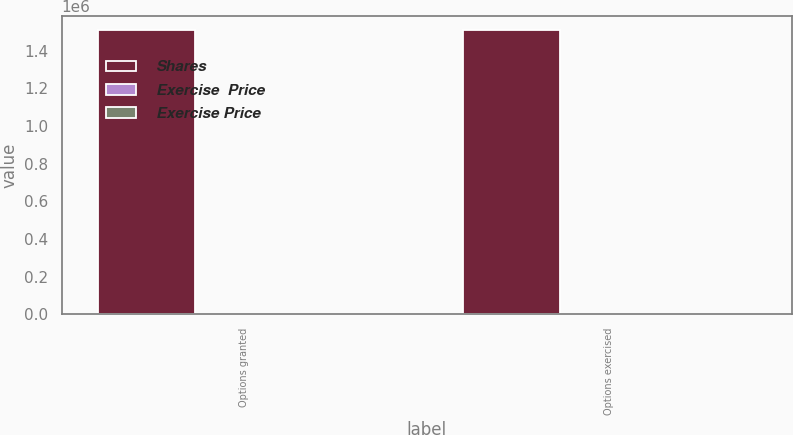<chart> <loc_0><loc_0><loc_500><loc_500><stacked_bar_chart><ecel><fcel>Options granted<fcel>Options exercised<nl><fcel>Shares<fcel>1.50734e+06<fcel>1.50734e+06<nl><fcel>Exercise  Price<fcel>69.34<fcel>69.34<nl><fcel>Exercise Price<fcel>65.25<fcel>65.25<nl></chart> 